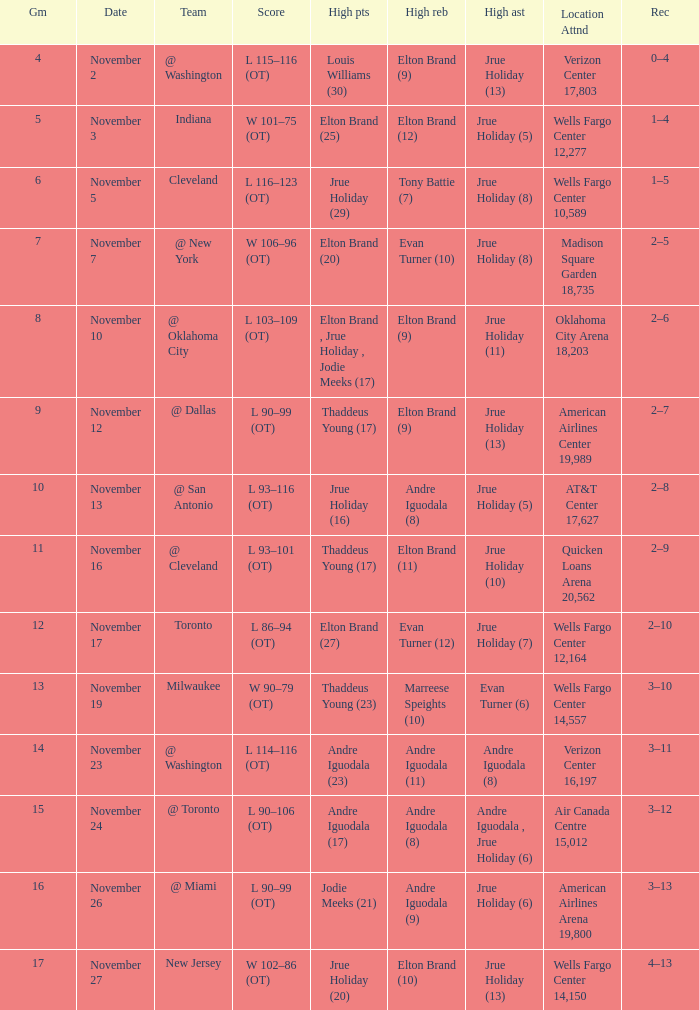How many games are shown for the game where andre iguodala (9) had the high rebounds? 1.0. 